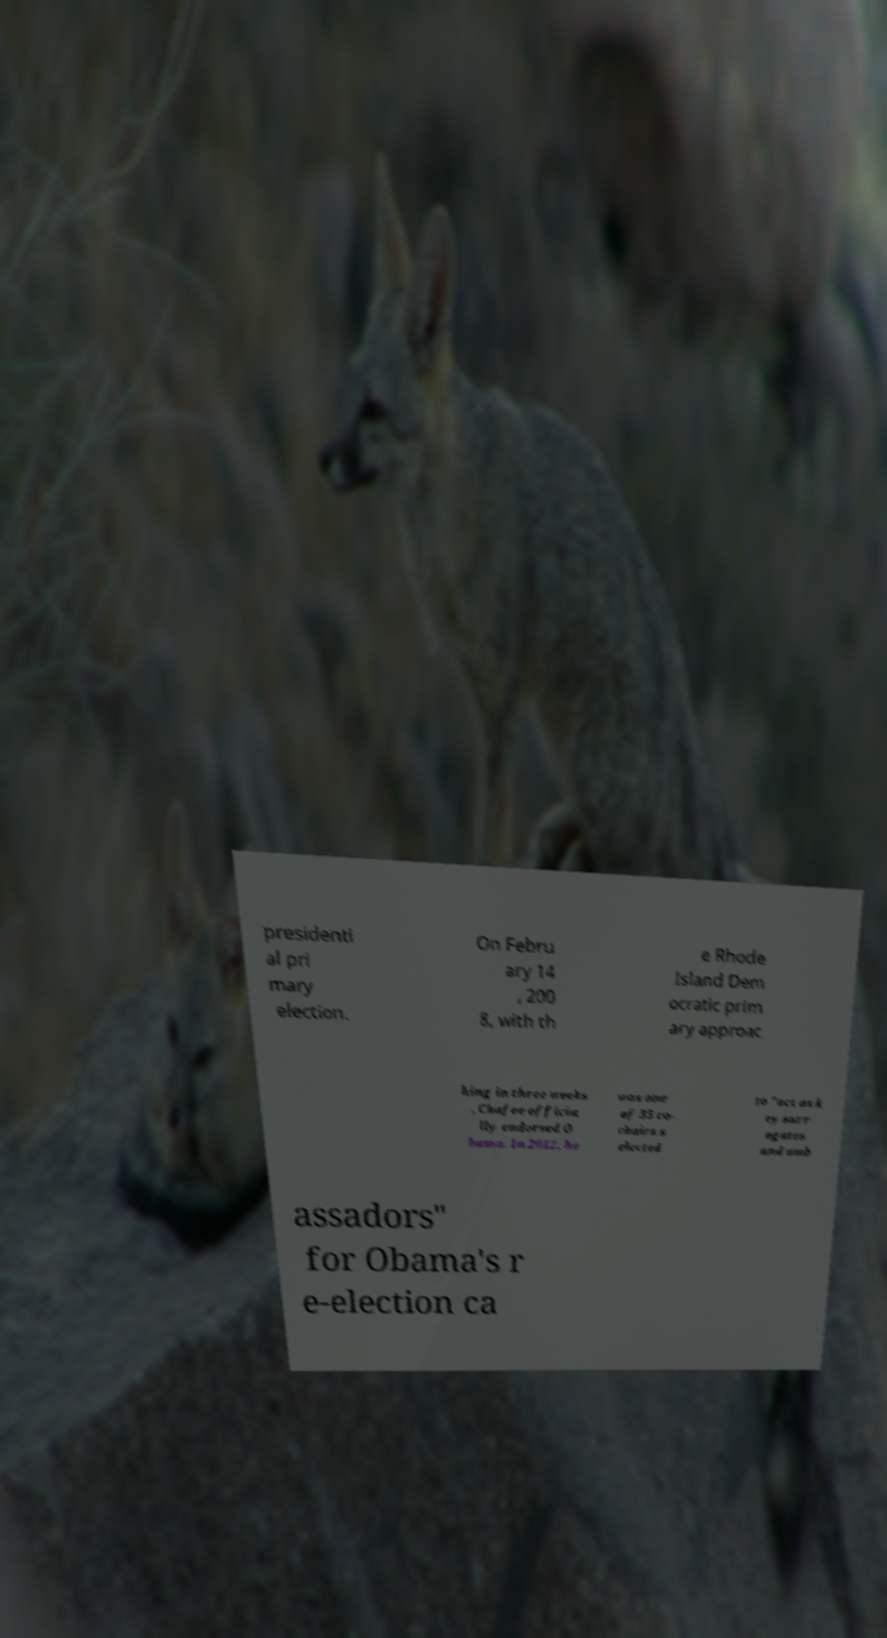Could you assist in decoding the text presented in this image and type it out clearly? presidenti al pri mary election. On Febru ary 14 , 200 8, with th e Rhode Island Dem ocratic prim ary approac hing in three weeks , Chafee officia lly endorsed O bama. In 2012, he was one of 35 co- chairs s elected to "act as k ey surr ogates and amb assadors" for Obama's r e-election ca 